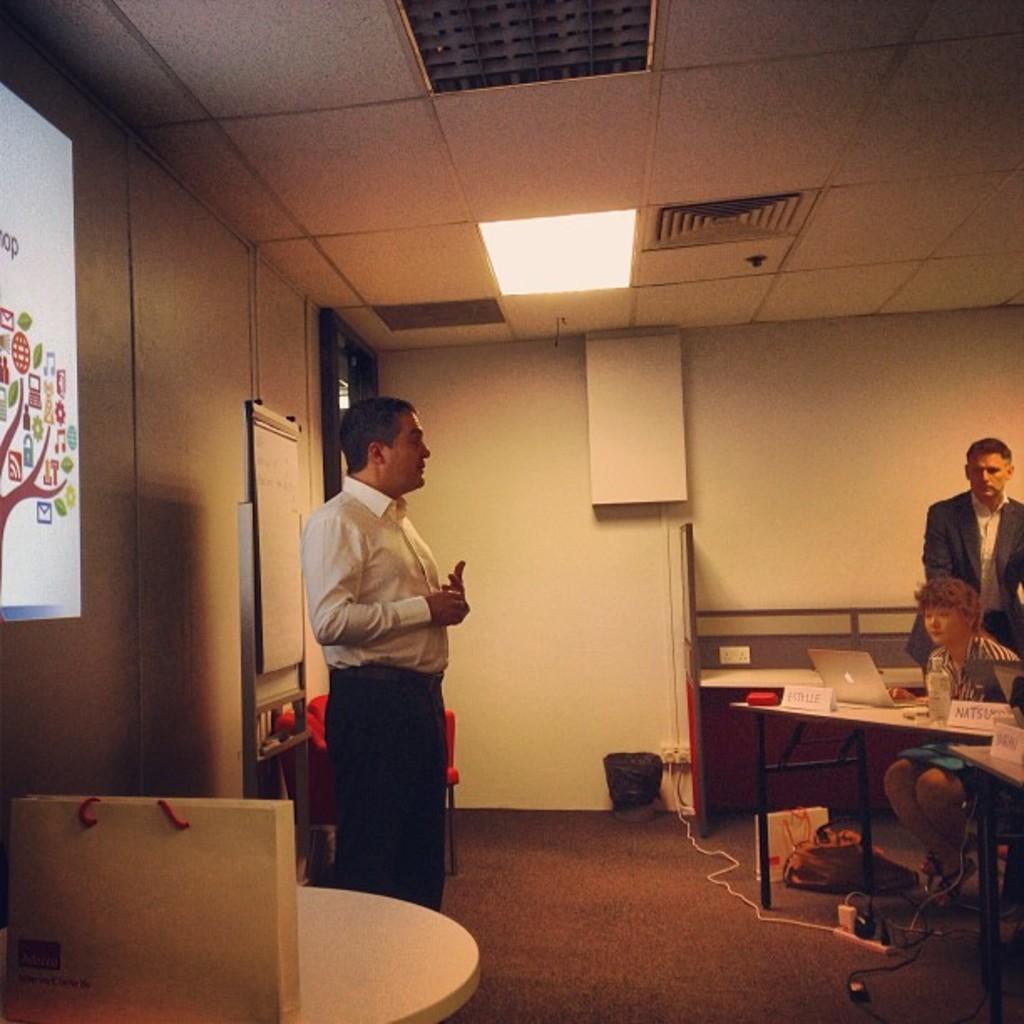How would you summarize this image in a sentence or two? This is a picture taken in a room, in the room there are a group of people some are sitting on chairs and some are standing on the floor in front of these people there is a table on the table there are name board, bottle and laptop. The man in white shirt was standing on the floor and explaining something. Behind the man there is a projector screen, wall, white board. Background of these people is a wall and there are ceiling lights on the top. 